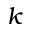<formula> <loc_0><loc_0><loc_500><loc_500>k</formula> 